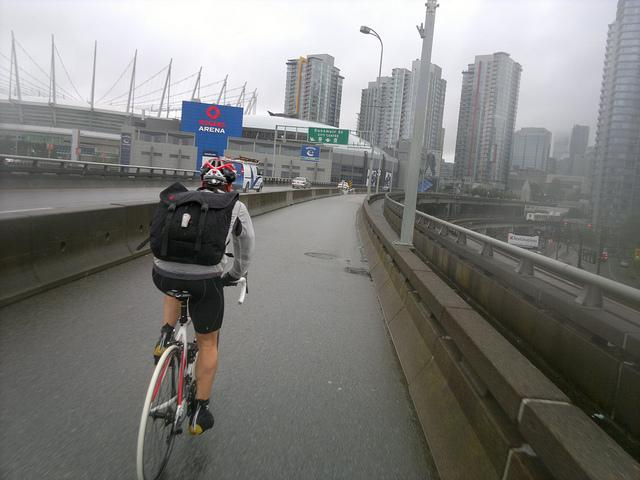What vehicles are allowed on the rightmost lane? bikes 